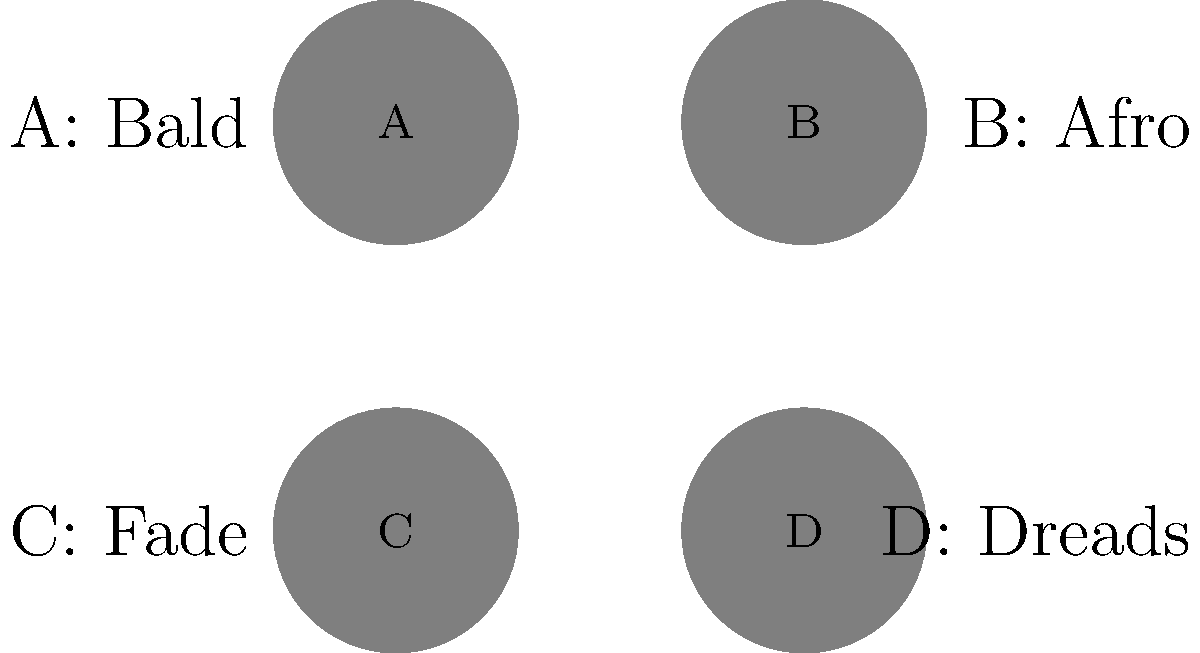Consider the permutation group of Anthony Anderson's four iconic hairstyles throughout his career, represented by the icons A (Bald), B (Afro), C (Fade), and D (Dreads). How many elements are in this permutation group? To determine the number of elements in the permutation group of Anthony Anderson's hairstyles, we need to follow these steps:

1. Recognize that we are dealing with a permutation group of 4 distinct elements (A, B, C, D).

2. Recall that the number of permutations of n distinct objects is given by n! (n factorial).

3. In this case, n = 4 (four hairstyles).

4. Calculate 4!:
   4! = 4 × 3 × 2 × 1 = 24

5. Therefore, there are 24 possible permutations of the four hairstyles.

6. In group theory, each permutation corresponds to an element in the permutation group.

Thus, the permutation group of Anthony Anderson's four hairstyles contains 24 elements.
Answer: 24 